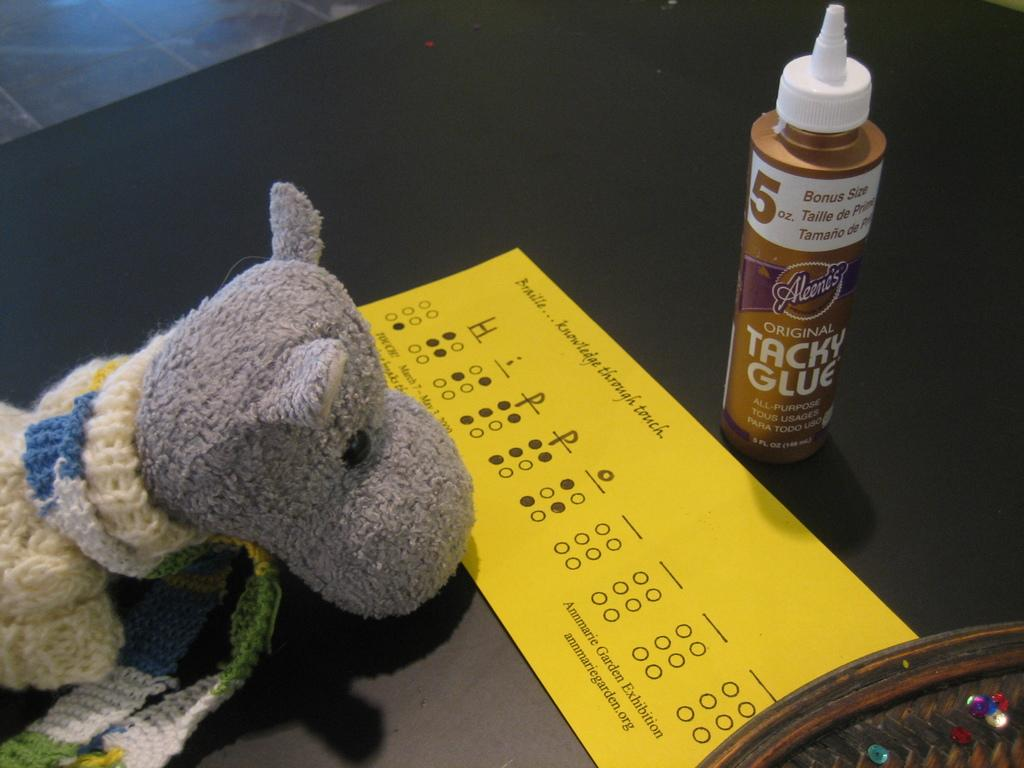Provide a one-sentence caption for the provided image. A can of Tacky Glue stands next to a yellow Braille test form. 